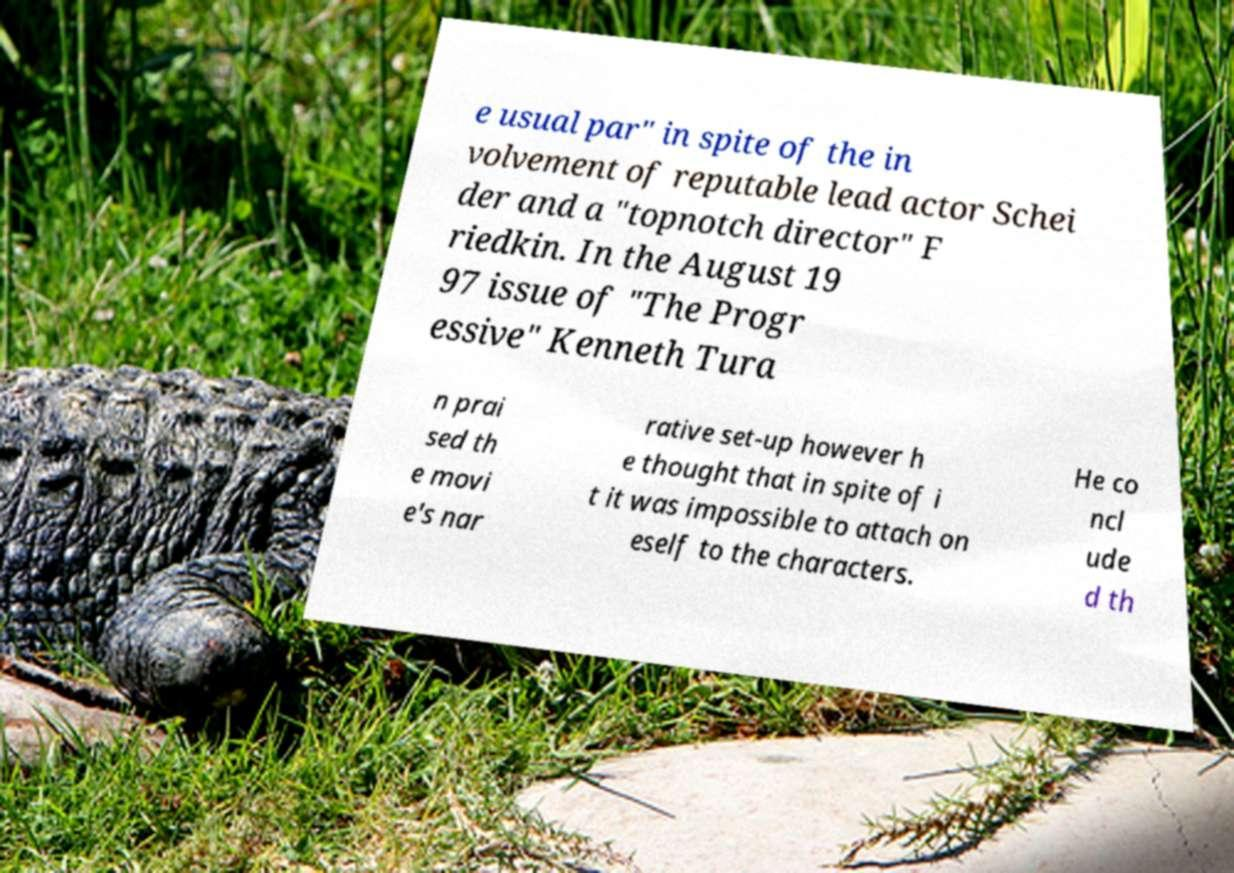Can you read and provide the text displayed in the image?This photo seems to have some interesting text. Can you extract and type it out for me? e usual par" in spite of the in volvement of reputable lead actor Schei der and a "topnotch director" F riedkin. In the August 19 97 issue of "The Progr essive" Kenneth Tura n prai sed th e movi e's nar rative set-up however h e thought that in spite of i t it was impossible to attach on eself to the characters. He co ncl ude d th 